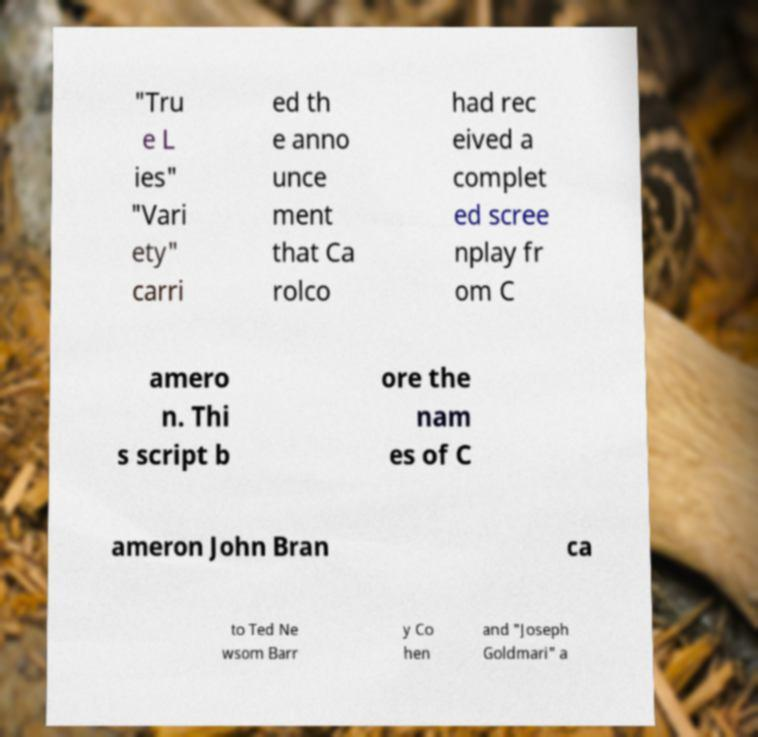Could you assist in decoding the text presented in this image and type it out clearly? "Tru e L ies" "Vari ety" carri ed th e anno unce ment that Ca rolco had rec eived a complet ed scree nplay fr om C amero n. Thi s script b ore the nam es of C ameron John Bran ca to Ted Ne wsom Barr y Co hen and "Joseph Goldmari" a 